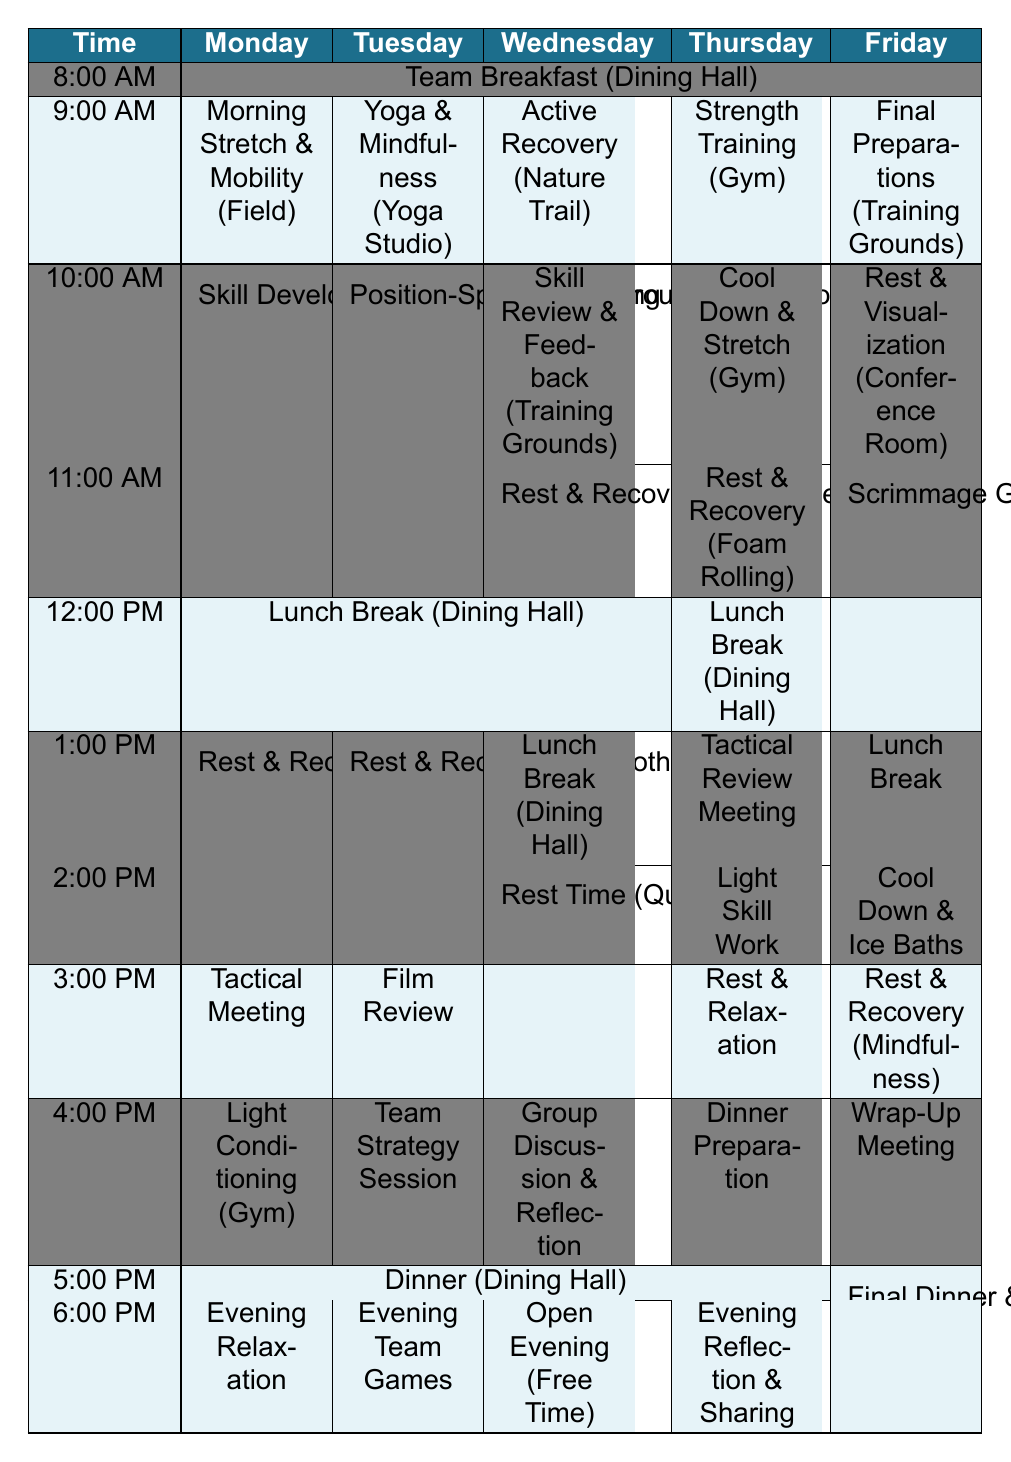What activity is scheduled for 9:00 AM on Tuesday? The table shows that on Tuesday at 9:00 AM, the activity is "Yoga and Mindfulness Session," which takes place in the "Yoga Studio."
Answer: Yoga and Mindfulness Session On which day is the "Active Recovery Day" scheduled? According to the table, the "Active Recovery Day" is scheduled for Wednesday at 9:00 AM, with a group walk taking place on the "Nature Trail."
Answer: Wednesday How many hours are dedicated to rest and recovery on Thursday? The table indicates that on Thursday, there are two scheduled times for rest and recovery: "Rest and Recovery (Foam Rolling)" for 1 hour at 11:00 AM, and "Rest and Relaxation Time" for 1 hour at 3:00 PM. Therefore, the total duration for rest and recovery on Thursday is 1 + 1 = 2 hours.
Answer: 2 hours Is there an evening relaxation activity on Monday? Yes, the table specifies that on Monday at 6:00 PM, there is "Evening Relaxation and Team Bonding" scheduled in the "Lounge."
Answer: Yes 